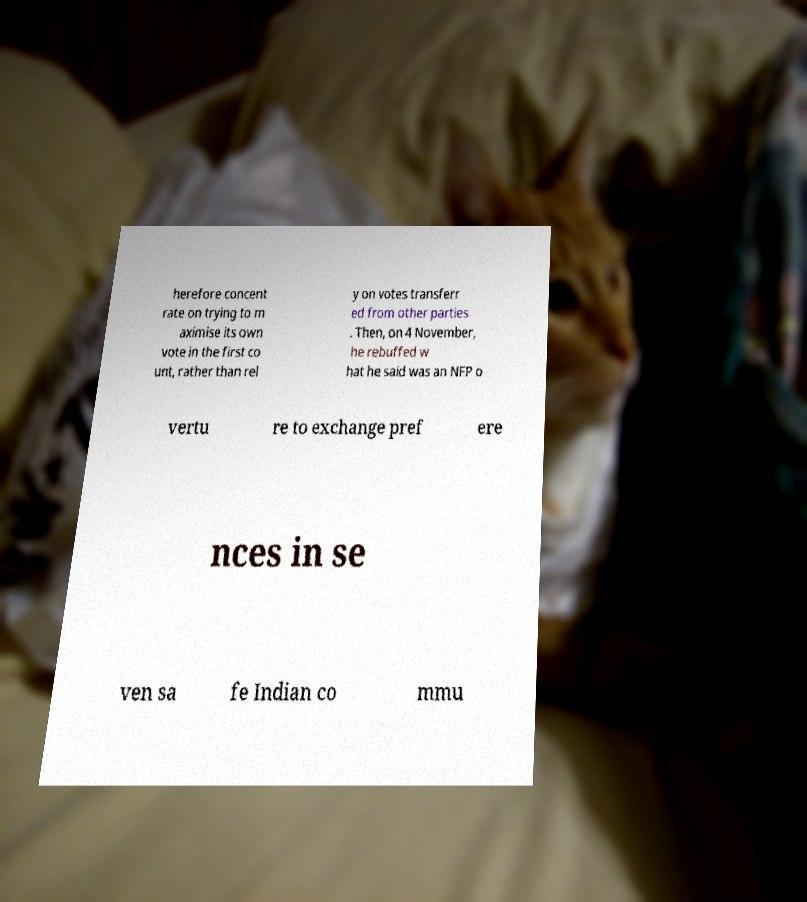There's text embedded in this image that I need extracted. Can you transcribe it verbatim? herefore concent rate on trying to m aximise its own vote in the first co unt, rather than rel y on votes transferr ed from other parties . Then, on 4 November, he rebuffed w hat he said was an NFP o vertu re to exchange pref ere nces in se ven sa fe Indian co mmu 